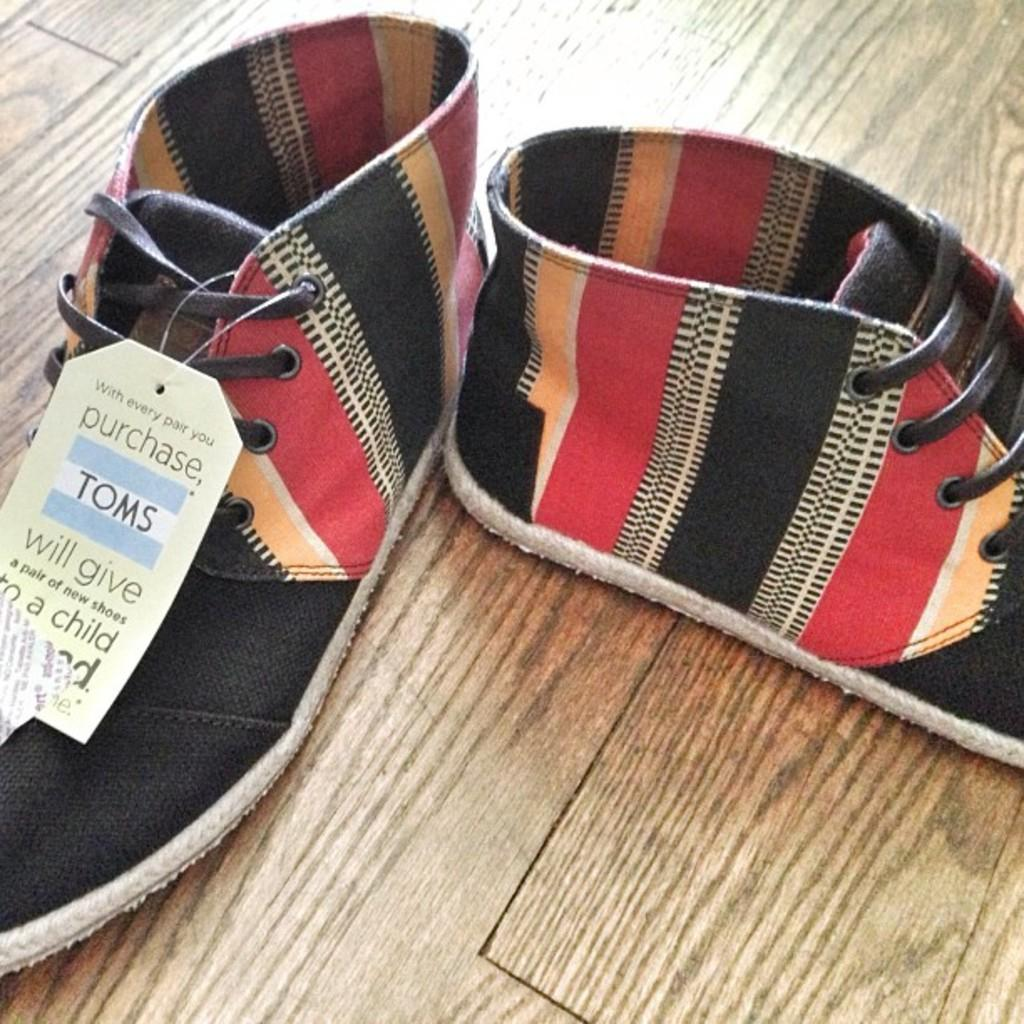What objects are in the image? There are shoes in the image. What is the shoes resting on? The shoes are on a wooden surface. Where are the shoes located in the image? The shoes are in the center of the image. What type of scarf is draped over the sun in the image? There is no scarf or sun present in the image; it only features shoes on a wooden surface. 